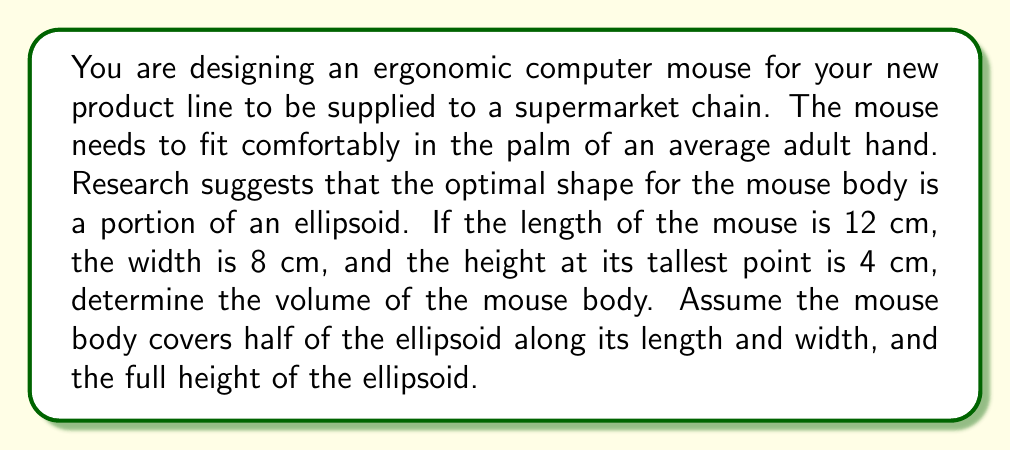Can you answer this question? To solve this problem, we need to follow these steps:

1) The shape we're dealing with is half of half an ellipsoid (quarter of a full ellipsoid). The formula for the volume of an ellipsoid is:

   $$V = \frac{4}{3}\pi abc$$

   where $a$, $b$, and $c$ are the semi-axes of the ellipsoid.

2) In our case:
   - Length (2a) = 12 cm, so a = 6 cm
   - Width (2b) = 8 cm, so b = 4 cm
   - Height (c) = 4 cm

3) Substituting these values into the formula:

   $$V_{full} = \frac{4}{3}\pi(6)(4)(4) = \frac{128}{3}\pi \approx 134.04 \text{ cm}^3$$

4) However, we only need a quarter of this volume, so we divide by 4:

   $$V_{mouse} = \frac{V_{full}}{4} = \frac{128}{12}\pi = \frac{32}{3}\pi \approx 33.51 \text{ cm}^3$$

Therefore, the volume of the mouse body is approximately 33.51 cubic centimeters.
Answer: $\frac{32}{3}\pi \approx 33.51 \text{ cm}^3$ 